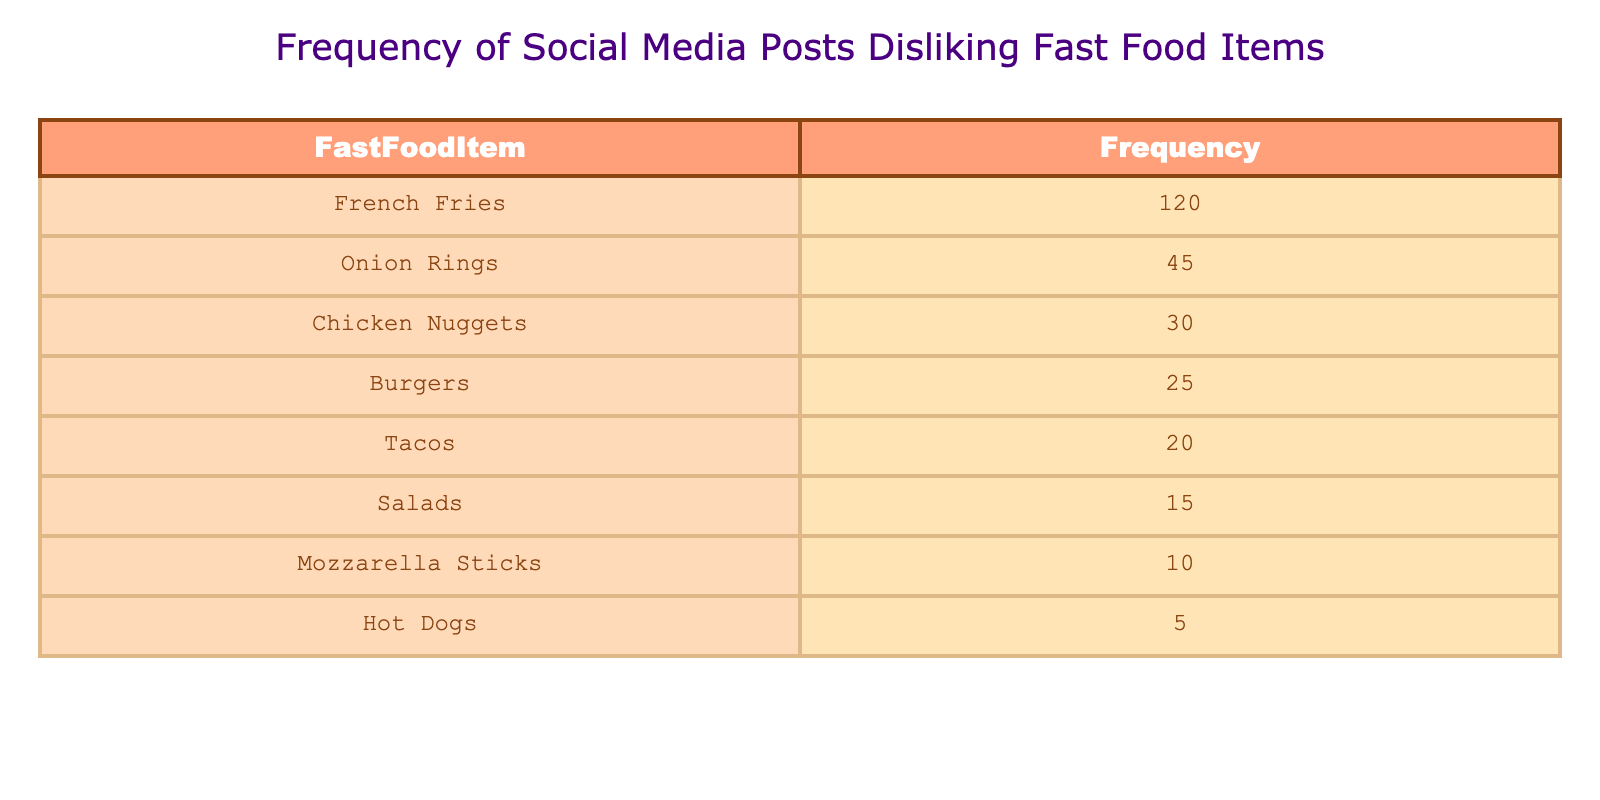What is the frequency of posts discussing French Fries? The table directly lists the frequency of posts for each fast food item. Looking at the row for French Fries, the frequency is indicated as 120.
Answer: 120 Which fast food item has the second-highest frequency of dislike? By checking the frequencies listed in the table, French Fries has the highest at 120, while Onion Rings have the second-highest frequency at 45, since that is the next highest number.
Answer: 45 How many more posts discuss the dislike of French Fries than Chicken Nuggets? To find the difference, we subtract the frequency of Chicken Nuggets (30) from that of French Fries (120). Calculating yields 120 - 30 = 90 more posts.
Answer: 90 Is the frequency of posts about Salad greater than that of Hot Dogs? Looking at the frequency for Salad (15) and Hot Dogs (5) in the table, Salad has a higher frequency. Since 15 is greater than 5, the answer is yes.
Answer: Yes What is the total frequency of posts discussing dislike for Burgers, Tacos, and Salads combined? We need to add the frequencies for Burgers (25), Tacos (20), and Salads (15). Calculating gives us 25 + 20 + 15 = 60 combined total.
Answer: 60 What percentage of the total dislike posts does French Fries account for? First, we need to find the total frequency by summing all items: 120 + 45 + 30 + 25 + 20 + 15 + 10 + 5 = 270. Then, the percentage is (120 / 270) * 100. Calculating gives approximately 44.44%.
Answer: 44.44% How many fast food items have a frequency below 20? We can count the items listed: Tacos (20), Salads (15), Mozzarella Sticks (10), and Hot Dogs (5). Only Salad (15), Mozzarella Sticks (10), and Hot Dogs (5) have frequencies below 20, making a total of 3 items.
Answer: 3 What is the difference in frequency between Onion Rings and Mozzarella Sticks? We take the frequency of Onion Rings (45) and subtract the frequency of Mozzarella Sticks (10). Thus, the difference is 45 - 10 = 35.
Answer: 35 Do more posts mention Chicken Nuggets than Tacos? The frequency for Chicken Nuggets is 30, while for Tacos, it is 20. Since 30 is greater than 20, the answer is yes.
Answer: Yes 